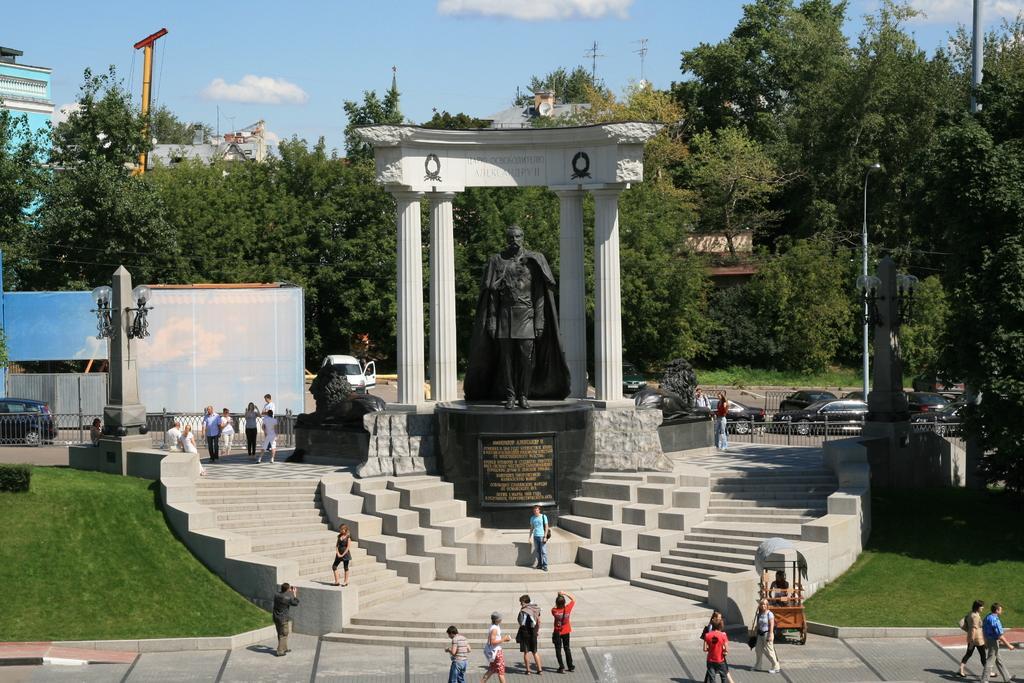In one or two sentences, can you explain what this image depicts? In this picture there is a statue in the foreground and there are staircases. There are group of people walking on the road and there are group of people standing. There are vehicles behind the railing. There are buildings, trees and poles. At the top there is sky and there are clouds. At the bottom there is a road and there is grass. 